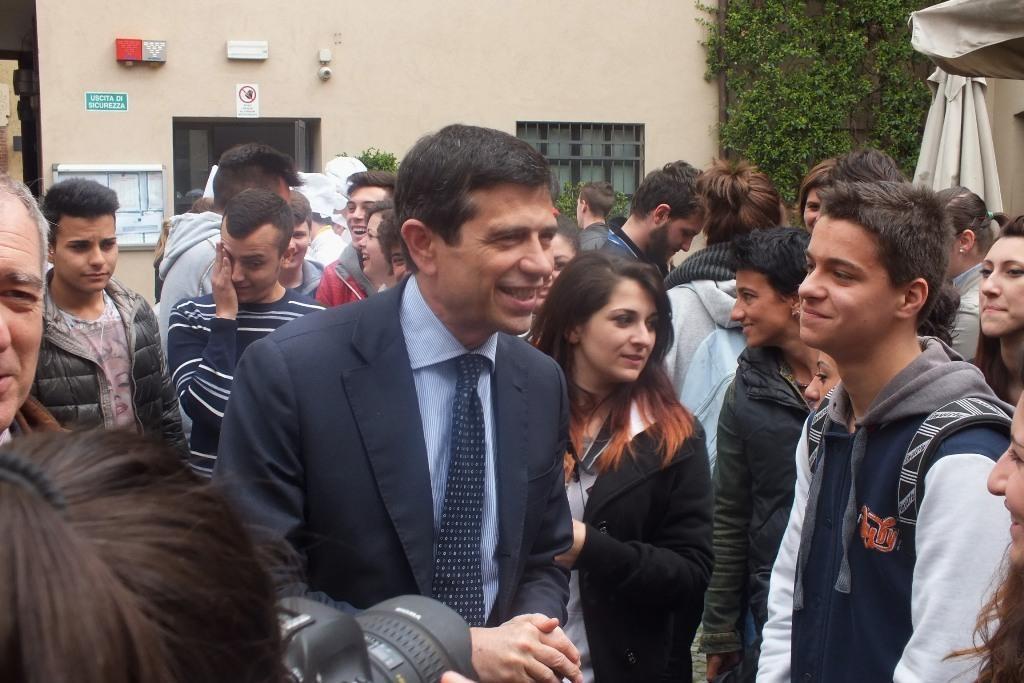Can you describe this image briefly? At the bottom of the image a person is standing and holding a camera. In the middle of the image few people are standing and smiling. Behind them there are some plants and trees and building. 